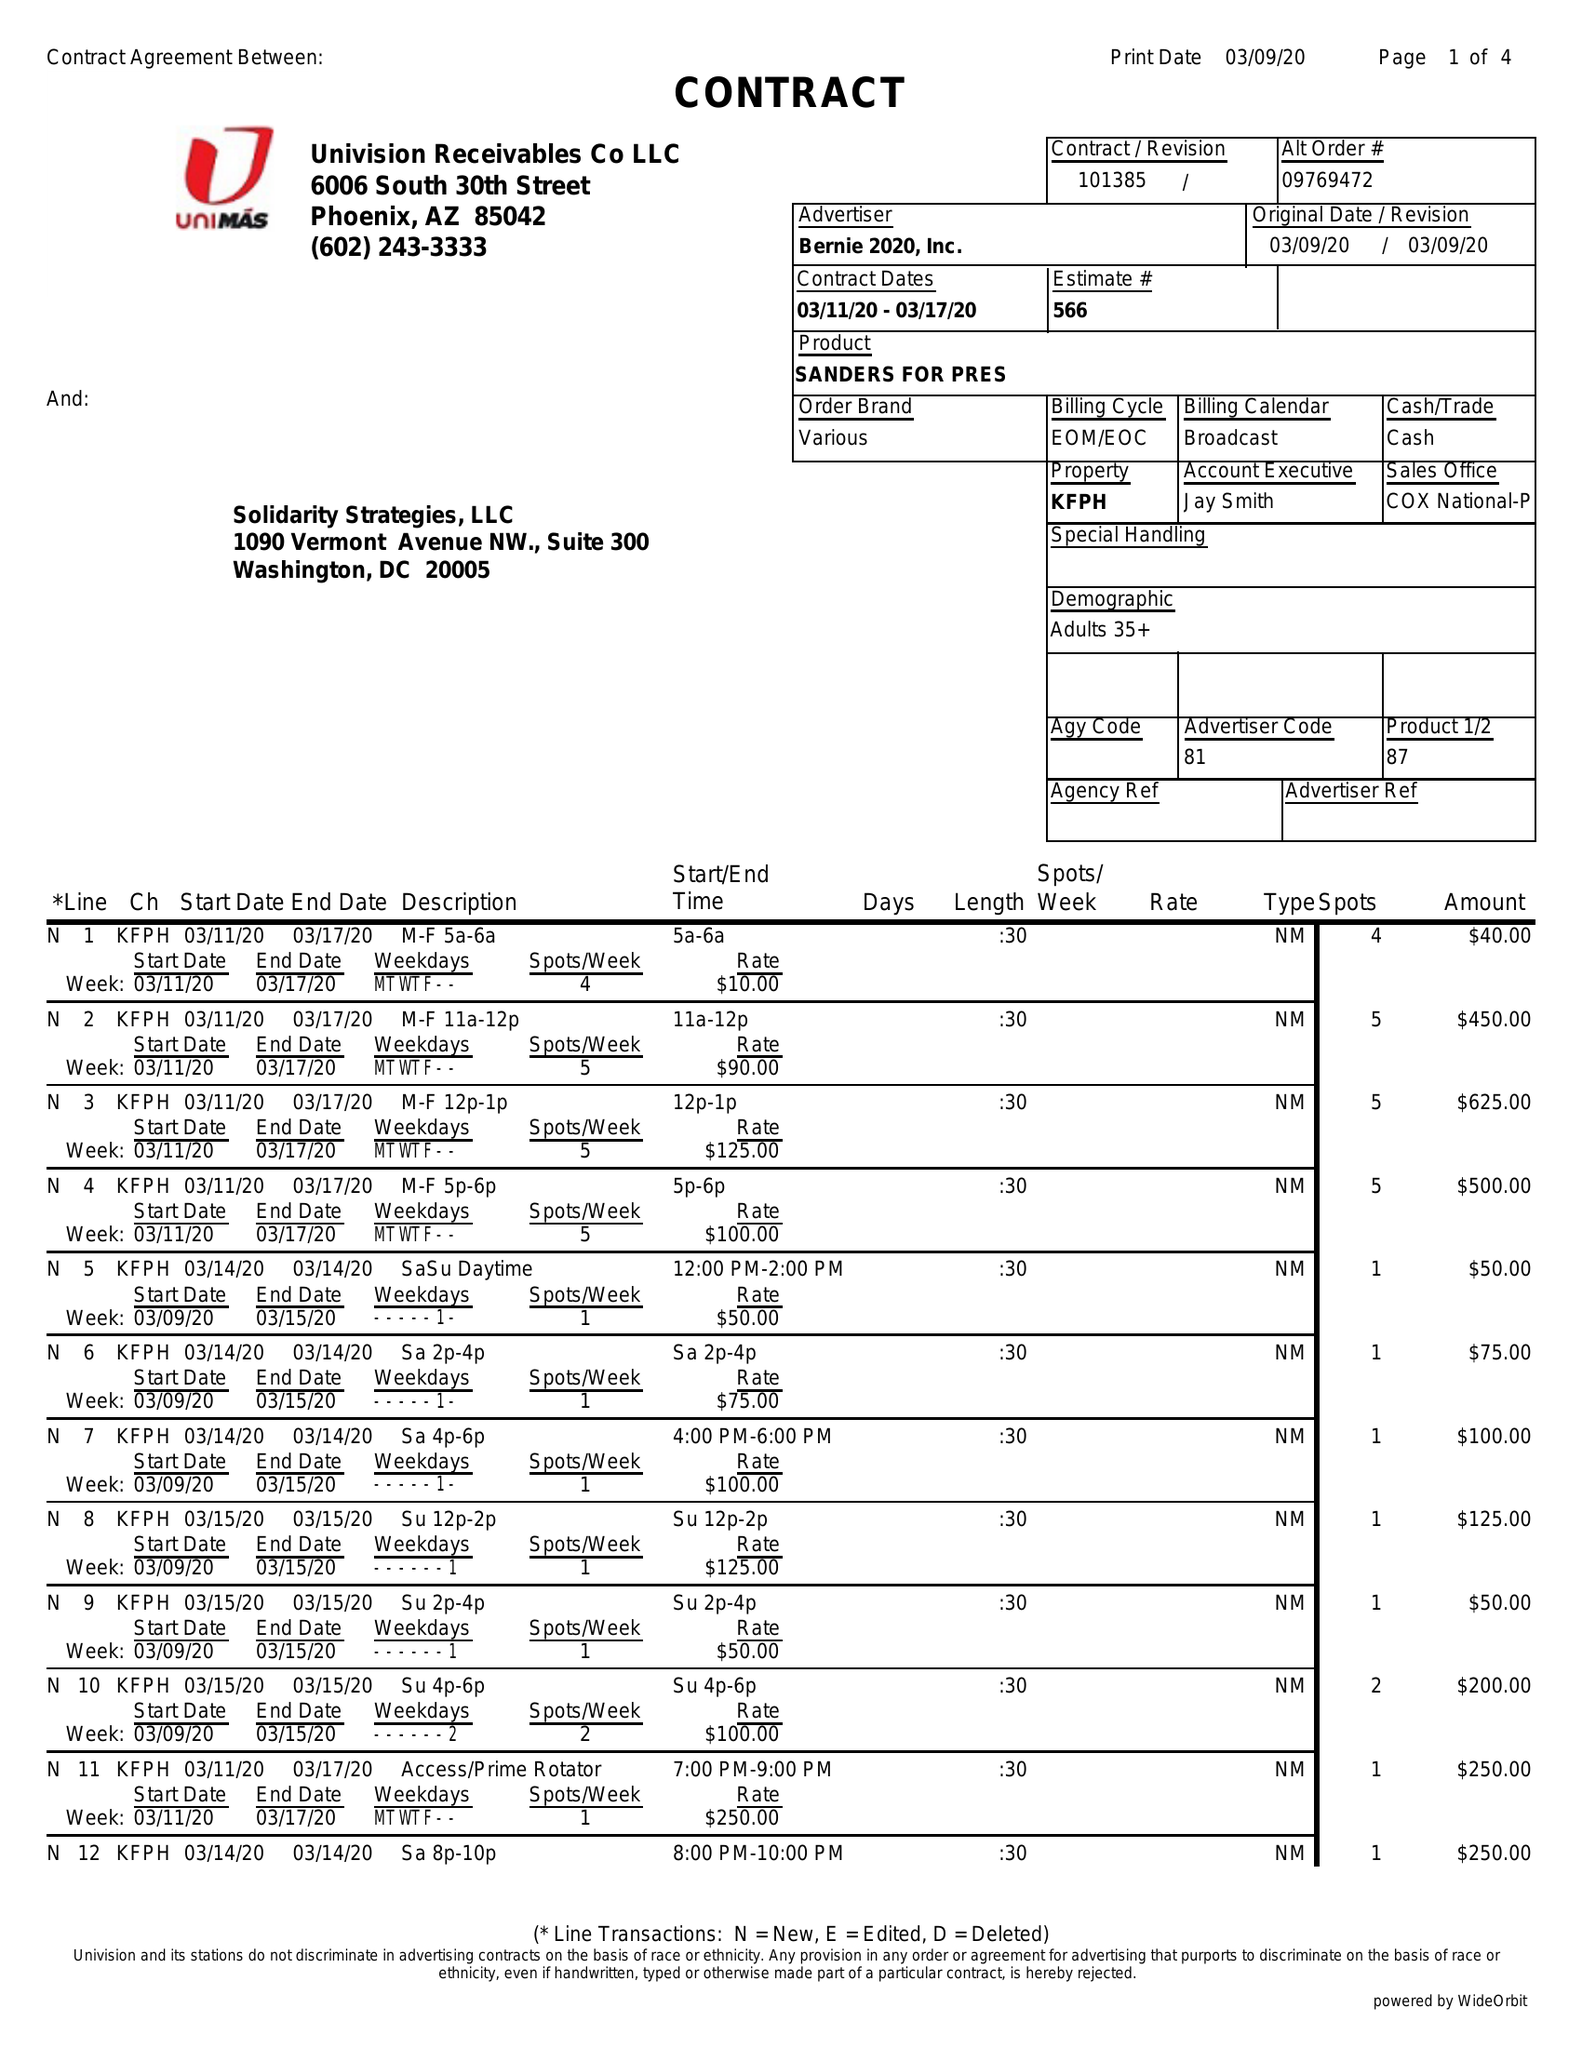What is the value for the flight_to?
Answer the question using a single word or phrase. 03/17/20 